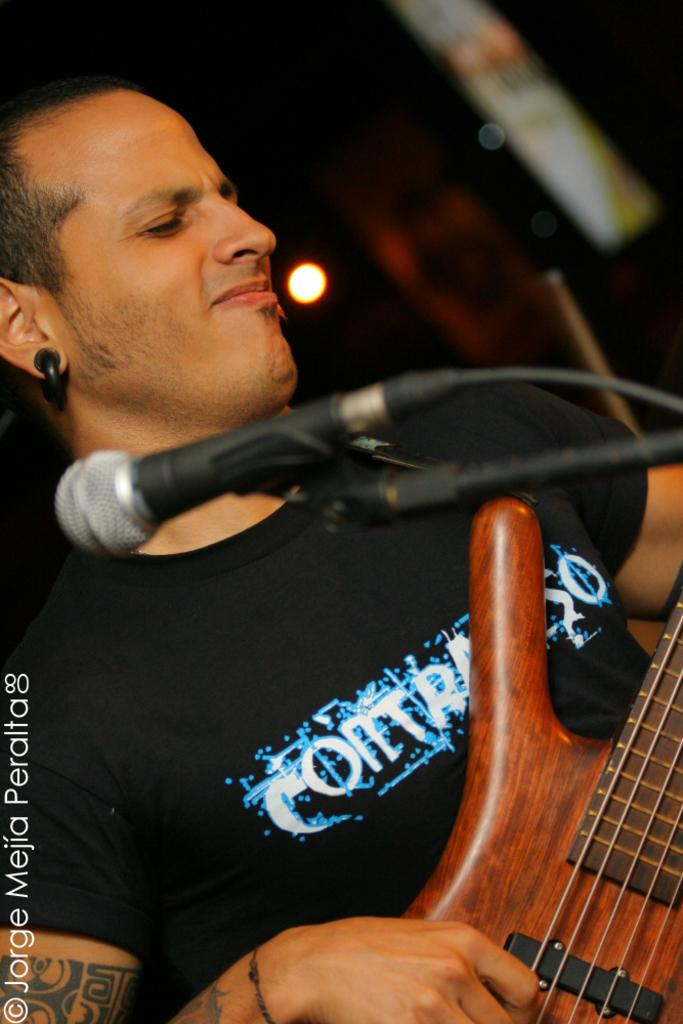Who is the main subject in the image? There is a man in the image. What is the man doing in the image? The man is playing a guitar. What object is present in the image that is commonly used for amplifying sound? There is a microphone in the image. What type of behavior can be observed in the sky in the image? There is no behavior to observe in the sky, as it is not a living entity and cannot exhibit behavior. 